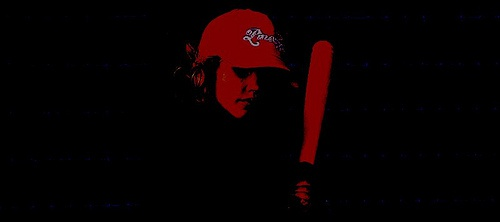Describe the objects in this image and their specific colors. I can see people in black, maroon, and gray tones, baseball bat in maroon and black tones, and baseball glove in maroon and black tones in this image. 